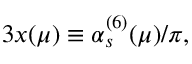<formula> <loc_0><loc_0><loc_500><loc_500>3 x ( \mu ) \equiv \alpha _ { s } ^ { ( 6 ) } ( \mu ) / \pi ,</formula> 